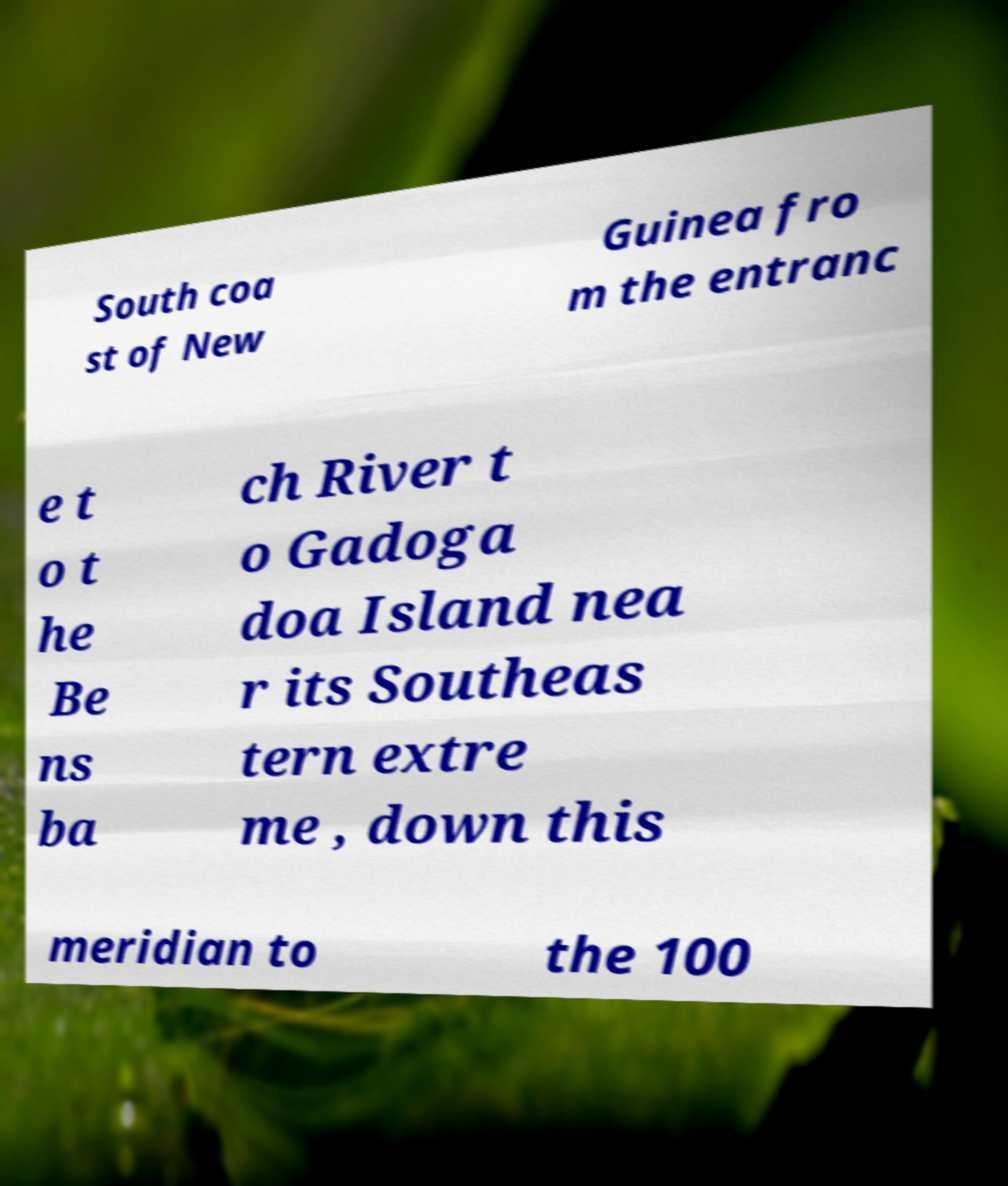There's text embedded in this image that I need extracted. Can you transcribe it verbatim? South coa st of New Guinea fro m the entranc e t o t he Be ns ba ch River t o Gadoga doa Island nea r its Southeas tern extre me , down this meridian to the 100 